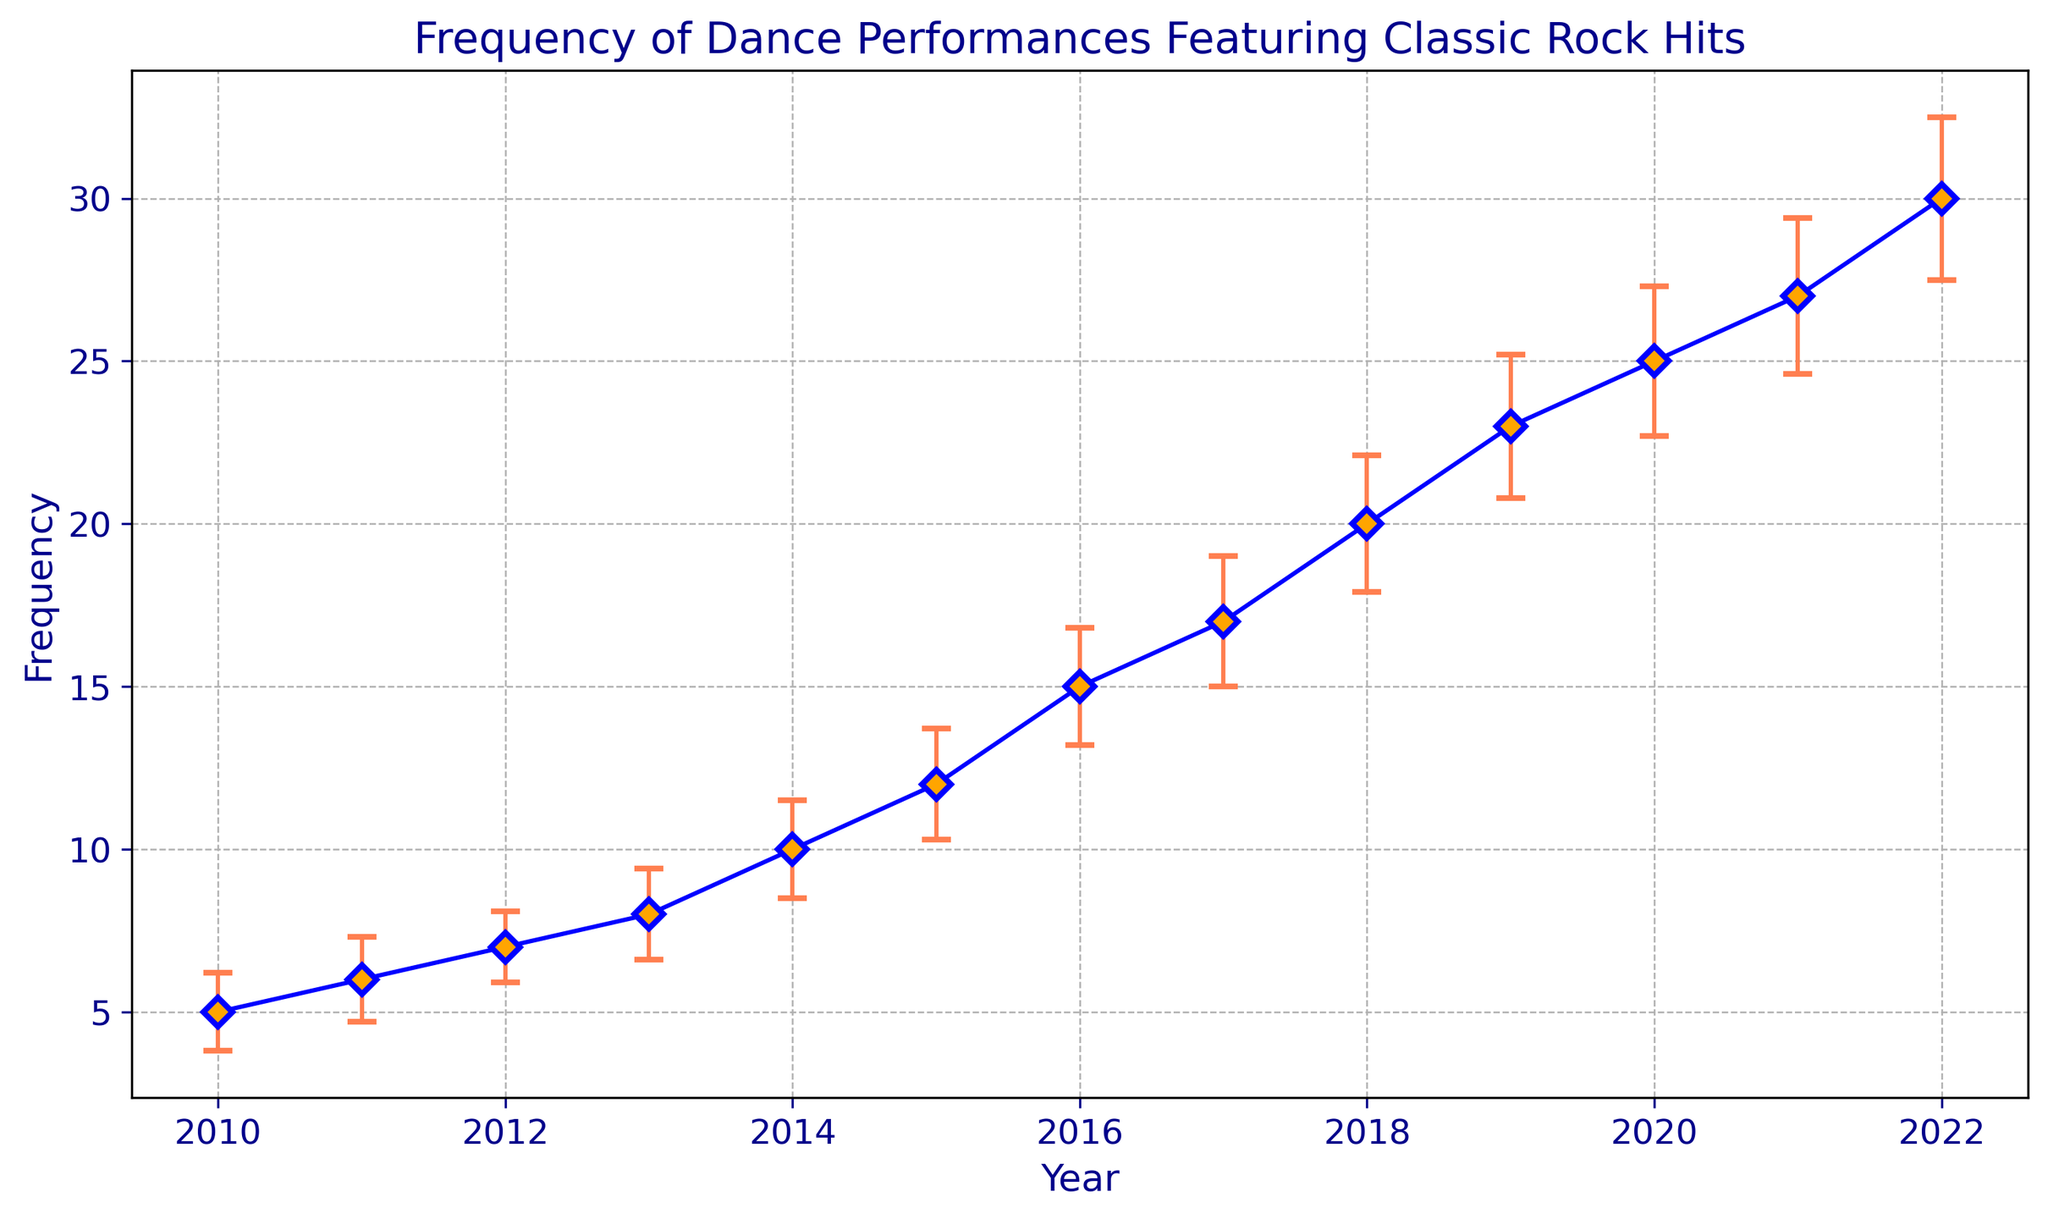What is the trend of the frequency of dance performances featuring classic rock hits from 2010 to 2022? The trend can be determined by observing the line connecting the data points on the plot. The line shows a steady increase in the frequency of performances from 2010 to 2022.
Answer: Increasing In which year did the frequency of dance performances featuring classic rock hits rise the most compared to the previous year? To find this, compare the differences between consecutive years. The largest increase occurred between 2019 (23) and 2020 (25), showing a rise of 7 performances.
Answer: 2019 to 2020 What is the total frequency of dance performances featuring classic rock hits from 2010 to 2015? Add the frequencies for the years 2010 (5), 2011 (6), 2012 (7), 2013 (8), 2014 (10), and 2015 (12). The sum is 5 + 6 + 7 + 8 + 10 + 12 = 48.
Answer: 48 Which year has the smallest frequency of dance performances featuring classic rock hits and what is the corresponding standard error for that year? The smallest frequency is in the year 2010 with a value of 5. The corresponding standard error for 2010 is 1.2.
Answer: 2010 and 1.2 For which year(s) are the standard errors greater than 2? The standard errors greater than 2 are for the years 2019 (2.2), 2020 (2.3), 2021 (2.4), and 2022 (2.5).
Answer: 2019, 2020, 2021, 2022 By how much did the average frequency of dance performances featuring classic rock hits increase per year? Calculate the average frequency increase by dividing the total increase (30 - 5 = 25) by the number of years (2022 - 2010 = 12). The average increase per year is 25/12 ≈ 2.08.
Answer: 2.08 In which year was the frequency closest to the half its value in 2022? Half of the frequency in 2022 (30) is 15. The frequency closest to 15 is in 2016, which is exactly 15.
Answer: 2016 What is the frequency difference between the highest and the lowest years? The highest frequency is in 2022 (30) and the lowest is in 2010 (5). The difference is 30 - 5 = 25.
Answer: 25 